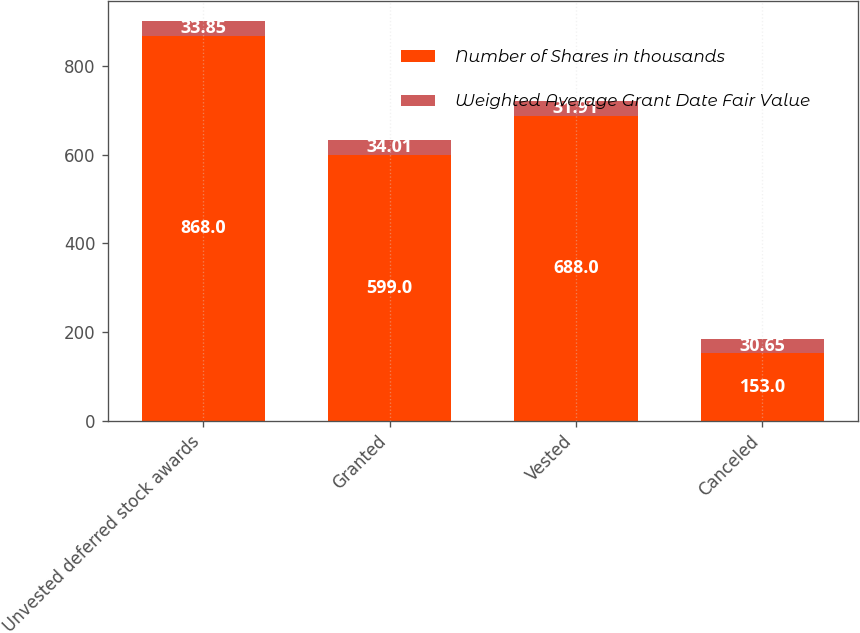Convert chart. <chart><loc_0><loc_0><loc_500><loc_500><stacked_bar_chart><ecel><fcel>Unvested deferred stock awards<fcel>Granted<fcel>Vested<fcel>Canceled<nl><fcel>Number of Shares in thousands<fcel>868<fcel>599<fcel>688<fcel>153<nl><fcel>Weighted Average Grant Date Fair Value<fcel>33.85<fcel>34.01<fcel>31.91<fcel>30.65<nl></chart> 